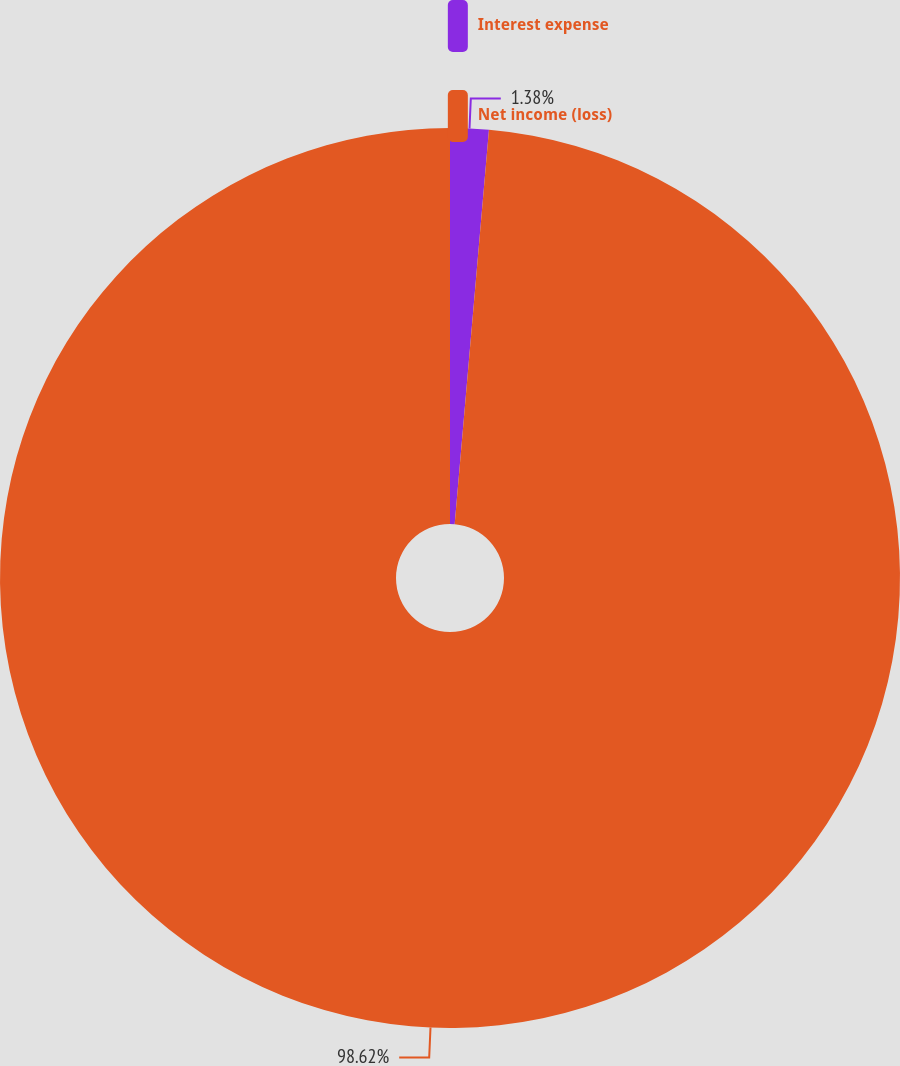Convert chart. <chart><loc_0><loc_0><loc_500><loc_500><pie_chart><fcel>Interest expense<fcel>Net income (loss)<nl><fcel>1.38%<fcel>98.62%<nl></chart> 